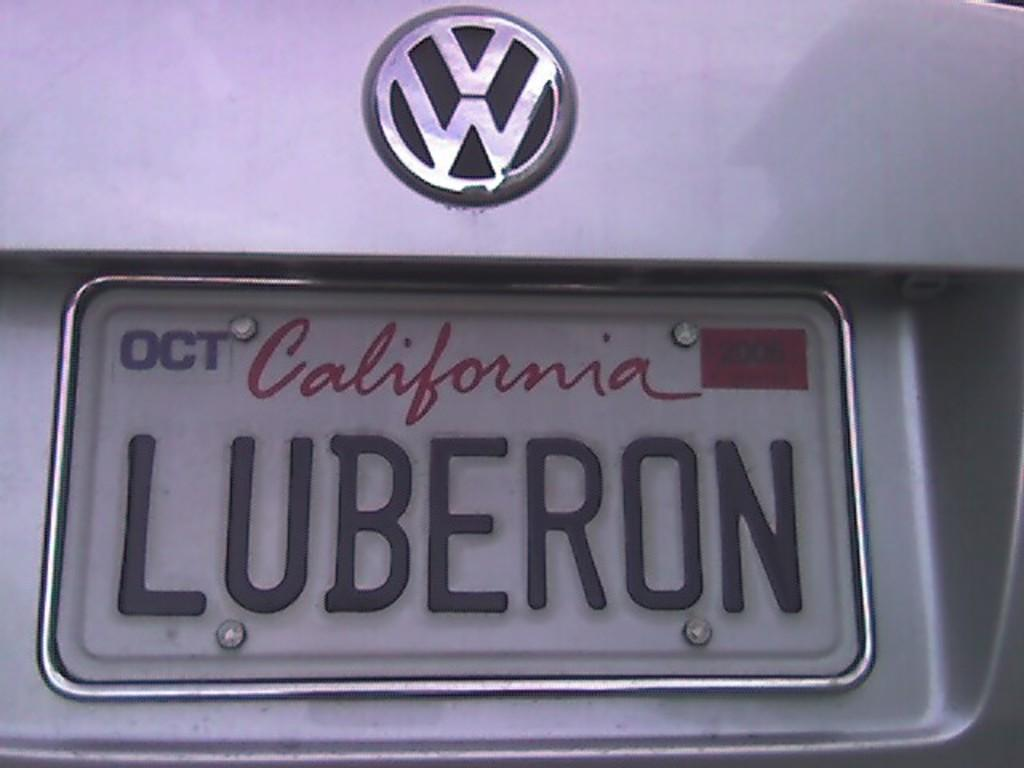<image>
Write a terse but informative summary of the picture. the word California is on the license plate 